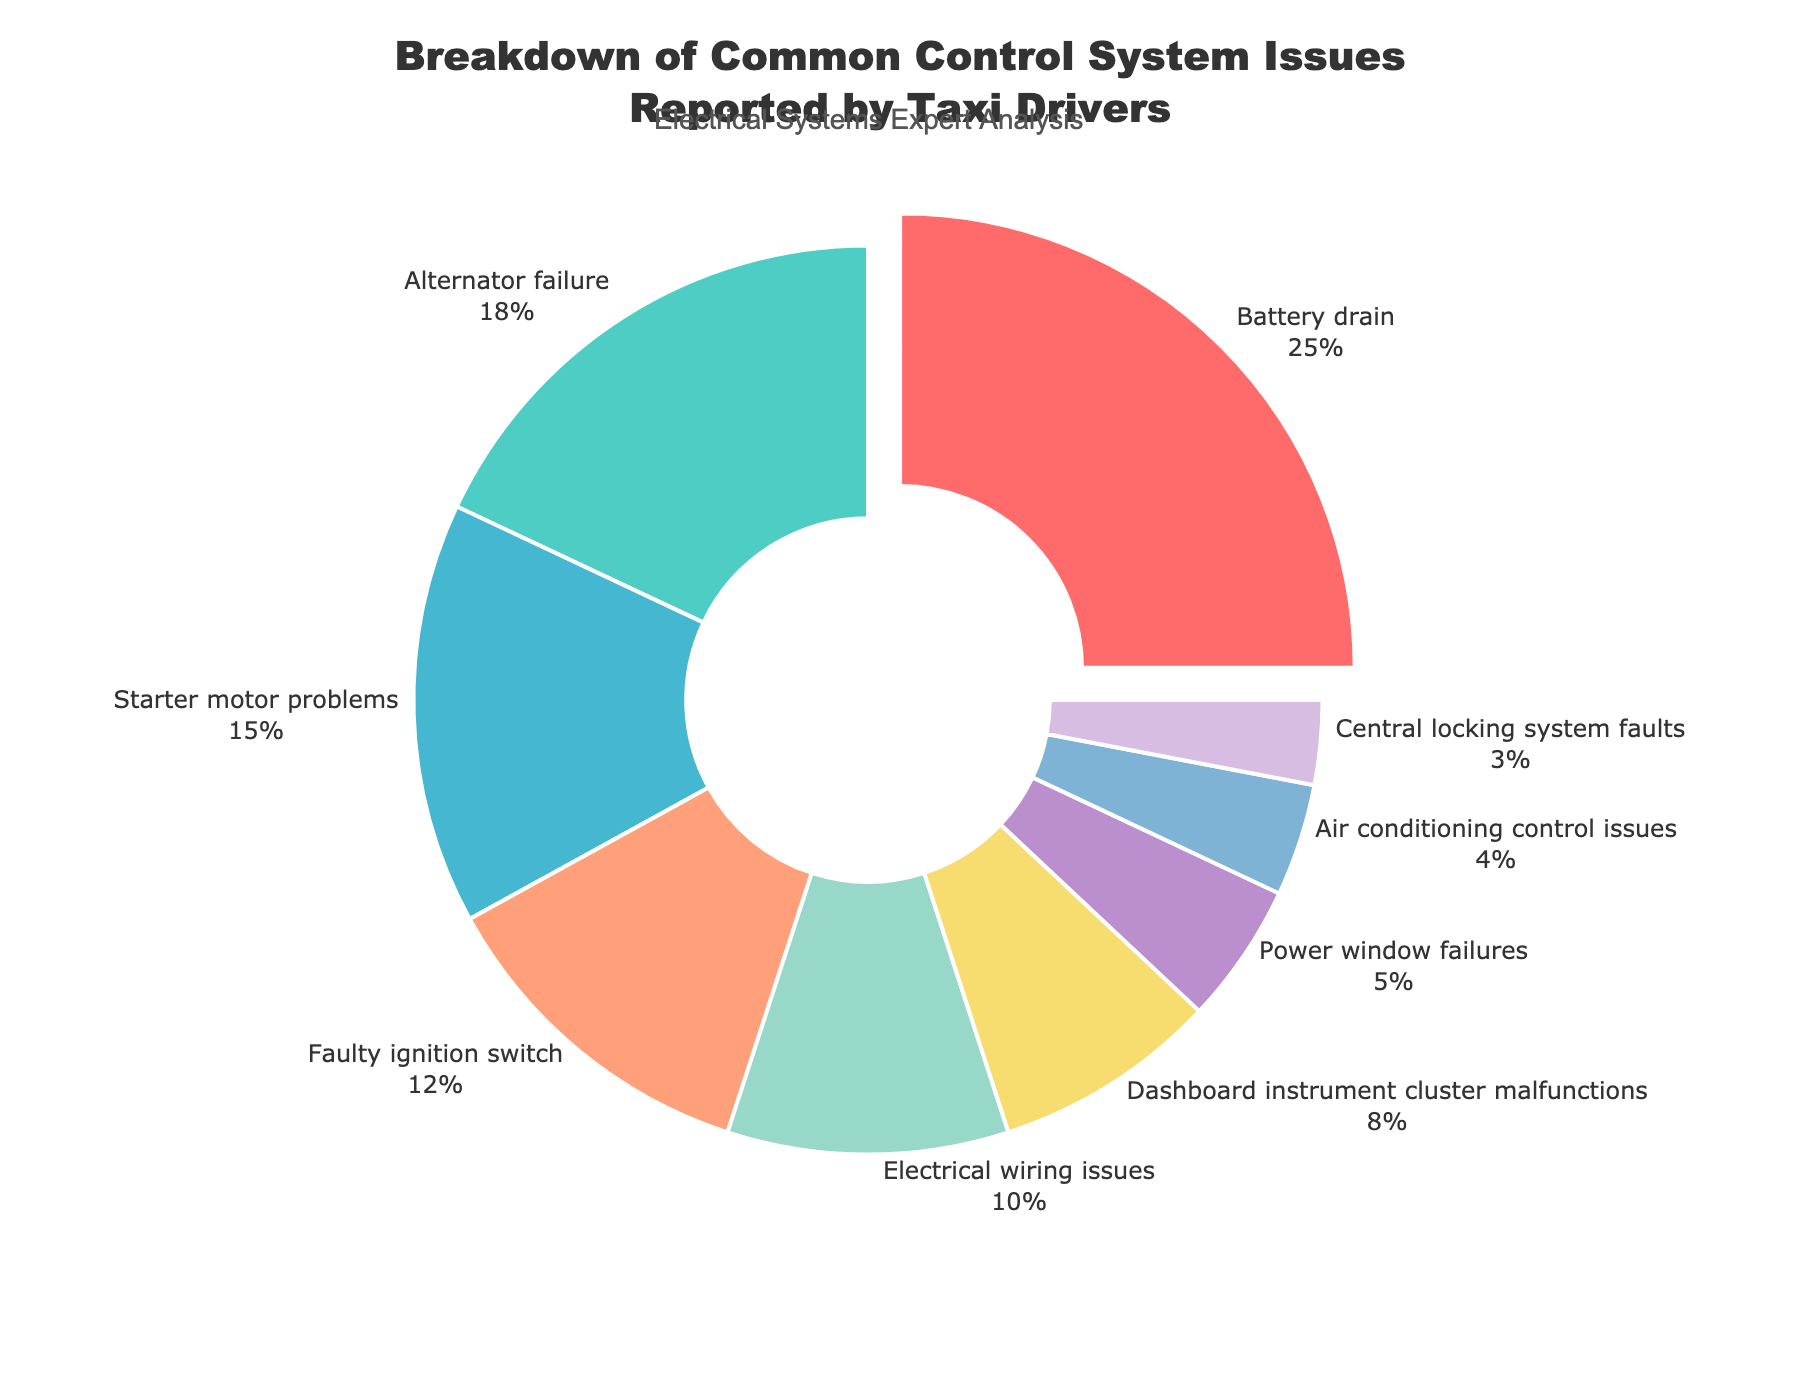Which issue has the highest percentage? The issue with the highest percentage is visually indicated as the largest slice in the pie chart. Additionally, it is slightly pulled out from the center.
Answer: Battery drain What is the combined percentage of alternator failure and starter motor problems? The chart shows alternator failure at 18% and starter motor problems at 15%. Adding these percentages together gives 18 + 15 = 33%.
Answer: 33% Are electrical wiring issues more or less common than dashboard instrument cluster malfunctions? By comparing the size of the pie slices, we can see that electrical wiring issues have a larger slice compared to dashboard instrument cluster malfunctions.
Answer: More common Which issues combined make up exactly half of the reported problems? Adding issues starting from the largest slice: Battery drain (25%), Alternator failure (18%), and Starter motor problems (15%) together equal 58%. Since this exceeds half, we check smaller combinations: Battery drain (25%) and Alternator failure (18%) add to 43%, and adding Faulty ignition switch (12%) reaches 55%. Therefore, Battery drain, Alternator failure, and Starter motor problems surpass the half mark. Only Battery drain and Alternator failure, however, do not. Instead, their combination yields nearly to half.
Answer: Battery drain and Alternator failure What percentage do the least common issues combined represent? The least common issues are power window failures (5%), air conditioning control issues (4%), and central locking system faults (3%). Adding these together gives 5 + 4 + 3 = 12%.
Answer: 12% Which issue is represented by the blue color slice? We look at the colors in the visual representation and identify the blue-colored slice. The pie chart's legend or direct labeling on the blue slice refers to Alternator failure, which is the second largest slice.
Answer: Alternator failure What is the difference in percentage between faulty ignition switch and power window failures? Faulty ignition switch is 12% and power window failures are 5%. Subtracting these values, 12 - 5 = 7%.
Answer: 7% Are air conditioning control issues more common than central locking system faults? By comparing the labeled percentage on the slices for both issues, air conditioning control issues (4%) have a larger percentage than central locking system faults (3%).
Answer: Yes Which issues are reported more frequently than 10%? By checking each slice’s label, issues with percentages higher than 10% are Battery drain (25%), Alternator failure (18%), Starter motor problems (15%), and Faulty ignition switch (12%).
Answer: Battery drain, Alternator failure, Starter motor problems, and Faulty ignition switch 